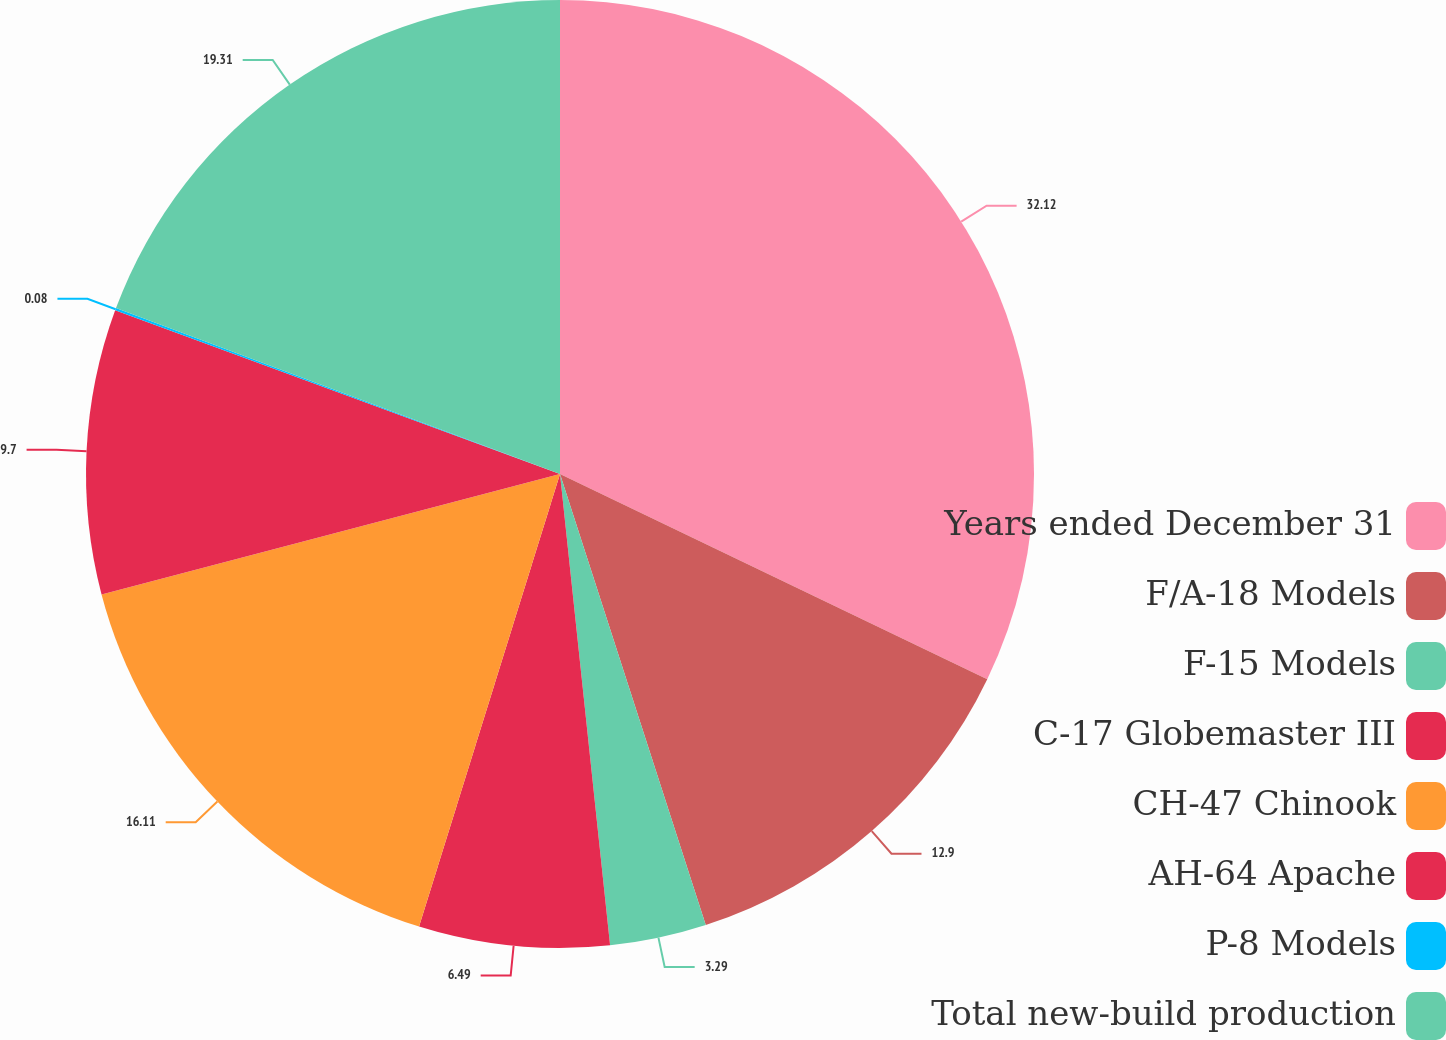Convert chart. <chart><loc_0><loc_0><loc_500><loc_500><pie_chart><fcel>Years ended December 31<fcel>F/A-18 Models<fcel>F-15 Models<fcel>C-17 Globemaster III<fcel>CH-47 Chinook<fcel>AH-64 Apache<fcel>P-8 Models<fcel>Total new-build production<nl><fcel>32.13%<fcel>12.9%<fcel>3.29%<fcel>6.49%<fcel>16.11%<fcel>9.7%<fcel>0.08%<fcel>19.31%<nl></chart> 